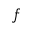<formula> <loc_0><loc_0><loc_500><loc_500>f</formula> 